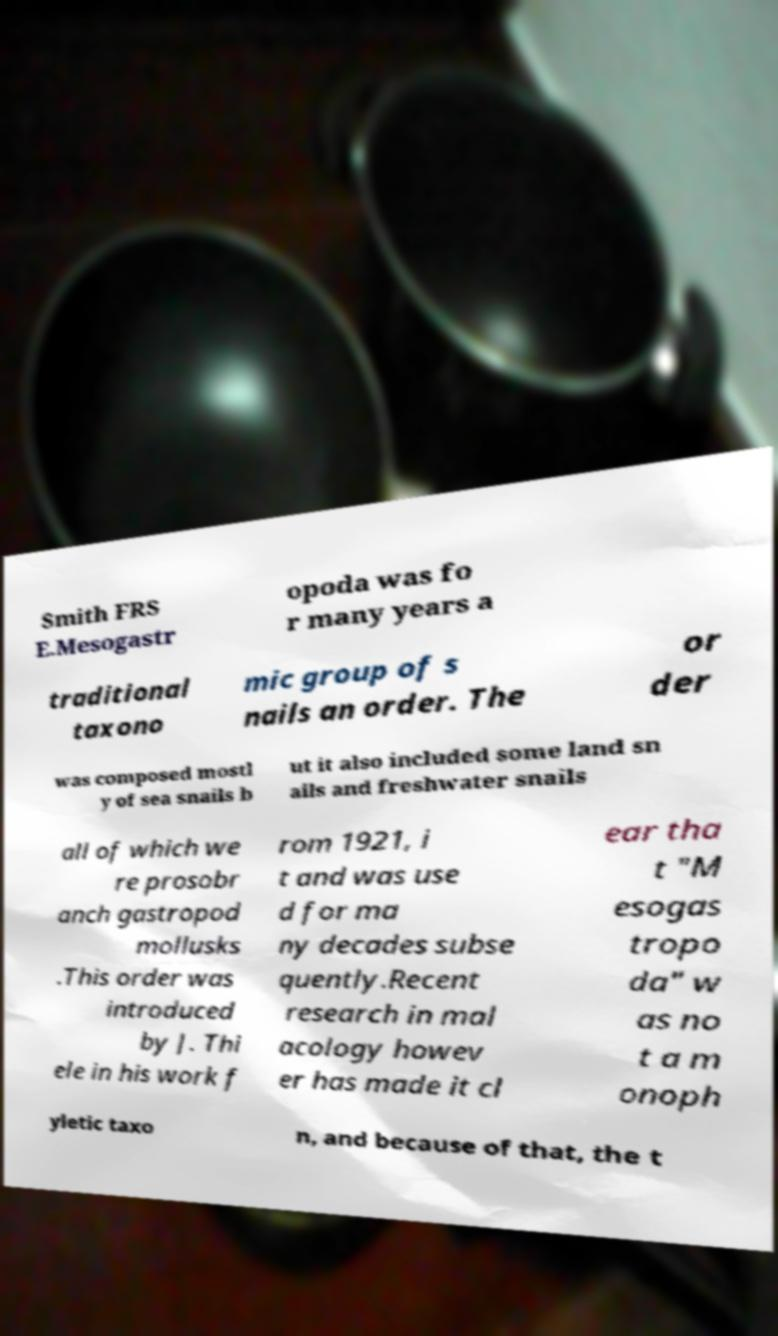Could you extract and type out the text from this image? Smith FRS E.Mesogastr opoda was fo r many years a traditional taxono mic group of s nails an order. The or der was composed mostl y of sea snails b ut it also included some land sn ails and freshwater snails all of which we re prosobr anch gastropod mollusks .This order was introduced by J. Thi ele in his work f rom 1921, i t and was use d for ma ny decades subse quently.Recent research in mal acology howev er has made it cl ear tha t "M esogas tropo da" w as no t a m onoph yletic taxo n, and because of that, the t 